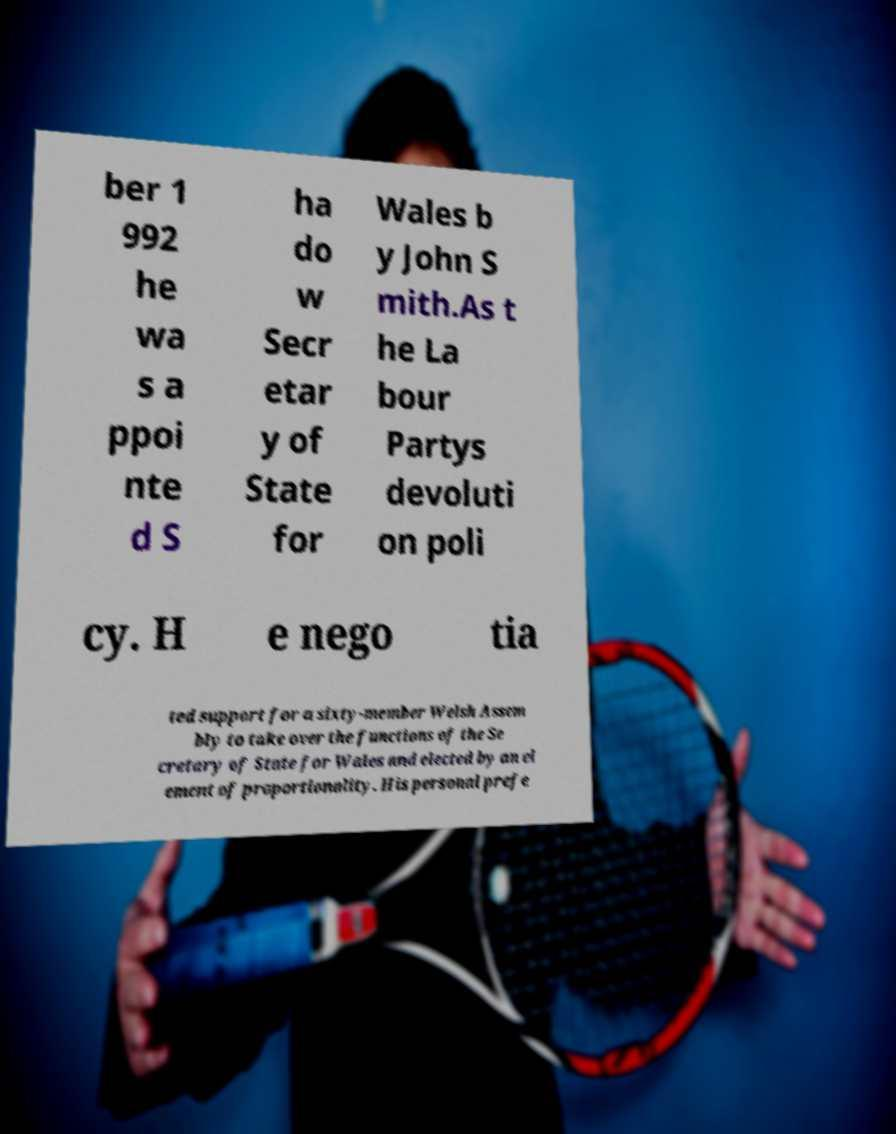Could you extract and type out the text from this image? ber 1 992 he wa s a ppoi nte d S ha do w Secr etar y of State for Wales b y John S mith.As t he La bour Partys devoluti on poli cy. H e nego tia ted support for a sixty-member Welsh Assem bly to take over the functions of the Se cretary of State for Wales and elected by an el ement of proportionality. His personal prefe 